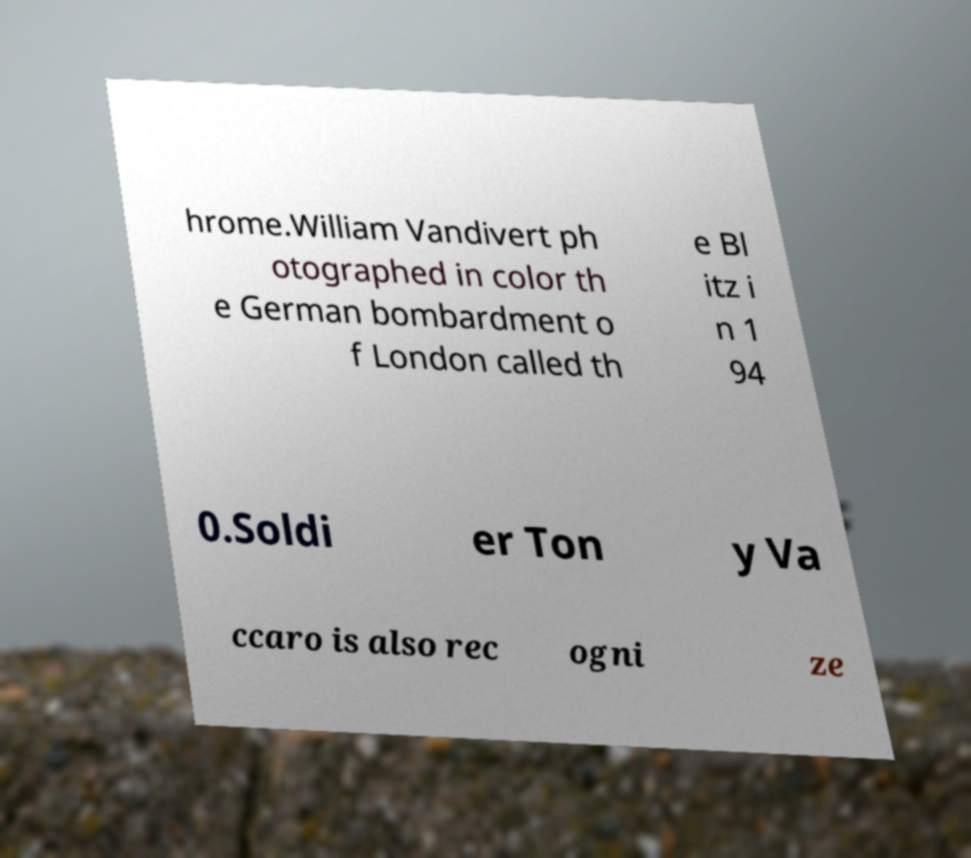What messages or text are displayed in this image? I need them in a readable, typed format. hrome.William Vandivert ph otographed in color th e German bombardment o f London called th e Bl itz i n 1 94 0.Soldi er Ton y Va ccaro is also rec ogni ze 